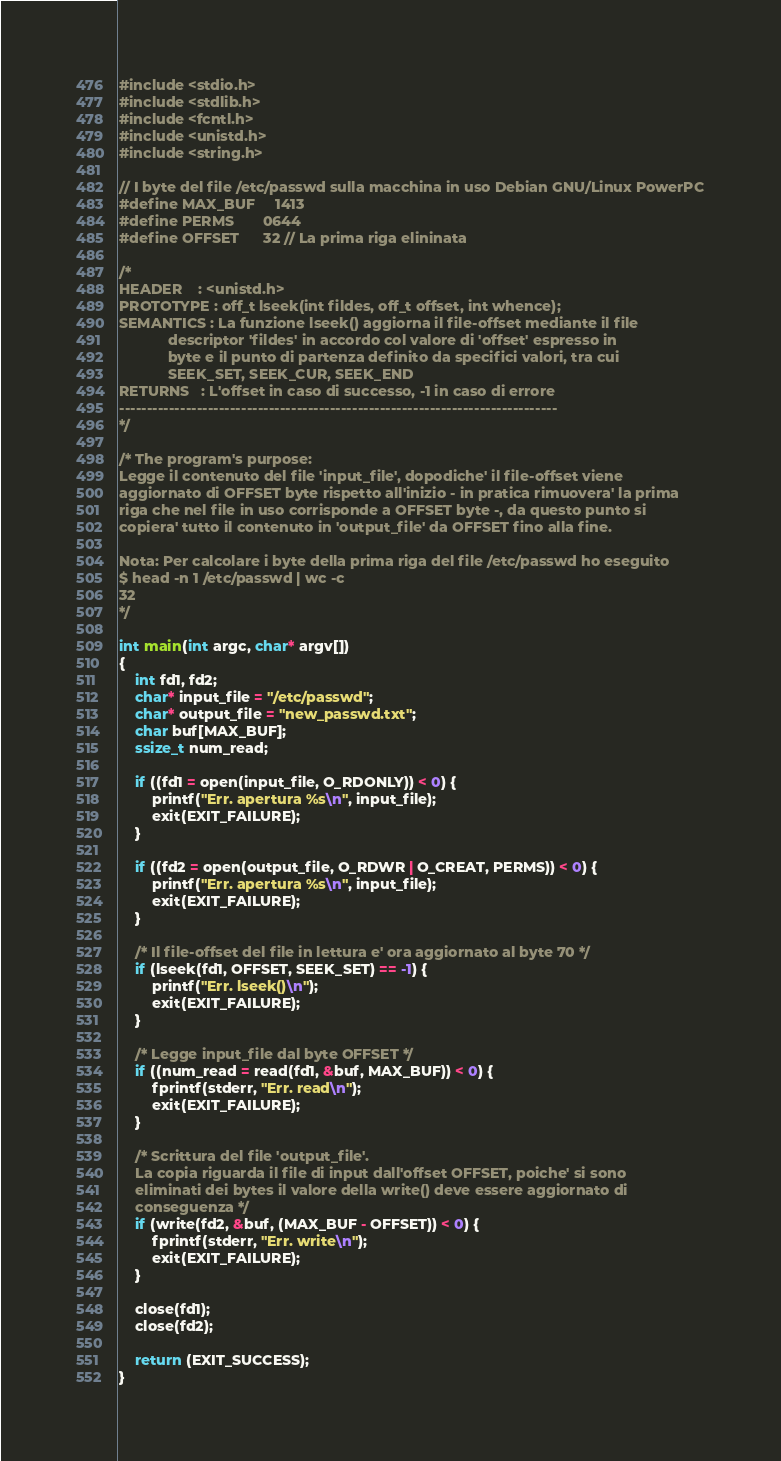<code> <loc_0><loc_0><loc_500><loc_500><_C_>#include <stdio.h>
#include <stdlib.h>
#include <fcntl.h>
#include <unistd.h>
#include <string.h>

// I byte del file /etc/passwd sulla macchina in uso Debian GNU/Linux PowerPC
#define MAX_BUF     1413
#define PERMS       0644
#define OFFSET      32 // La prima riga elininata

/*
HEADER    : <unistd.h>
PROTOTYPE : off_t lseek(int fildes, off_t offset, int whence);
SEMANTICS : La funzione lseek() aggiorna il file-offset mediante il file
            descriptor 'fildes' in accordo col valore di 'offset' espresso in
            byte e il punto di partenza definito da specifici valori, tra cui
            SEEK_SET, SEEK_CUR, SEEK_END
RETURNS   : L'offset in caso di successo, -1 in caso di errore
-------------------------------------------------------------------------------
*/

/* The program's purpose:
Legge il contenuto del file 'input_file', dopodiche' il file-offset viene
aggiornato di OFFSET byte rispetto all'inizio - in pratica rimuovera' la prima
riga che nel file in uso corrisponde a OFFSET byte -, da questo punto si
copiera' tutto il contenuto in 'output_file' da OFFSET fino alla fine.

Nota: Per calcolare i byte della prima riga del file /etc/passwd ho eseguito
$ head -n 1 /etc/passwd | wc -c
32
*/

int main(int argc, char* argv[])
{
    int fd1, fd2;
    char* input_file = "/etc/passwd";
    char* output_file = "new_passwd.txt";
    char buf[MAX_BUF];
    ssize_t num_read;

    if ((fd1 = open(input_file, O_RDONLY)) < 0) {
        printf("Err. apertura %s\n", input_file);
        exit(EXIT_FAILURE);
    }

    if ((fd2 = open(output_file, O_RDWR | O_CREAT, PERMS)) < 0) {
        printf("Err. apertura %s\n", input_file);
        exit(EXIT_FAILURE);
    }

    /* Il file-offset del file in lettura e' ora aggiornato al byte 70 */
    if (lseek(fd1, OFFSET, SEEK_SET) == -1) {
        printf("Err. lseek()\n");
        exit(EXIT_FAILURE);
    }

    /* Legge input_file dal byte OFFSET */
    if ((num_read = read(fd1, &buf, MAX_BUF)) < 0) {
        fprintf(stderr, "Err. read\n");
        exit(EXIT_FAILURE);
    }

    /* Scrittura del file 'output_file'.
    La copia riguarda il file di input dall'offset OFFSET, poiche' si sono
    eliminati dei bytes il valore della write() deve essere aggiornato di
    conseguenza */
    if (write(fd2, &buf, (MAX_BUF - OFFSET)) < 0) {
        fprintf(stderr, "Err. write\n");
        exit(EXIT_FAILURE);
    }

    close(fd1);
    close(fd2);

    return (EXIT_SUCCESS);
}
</code> 